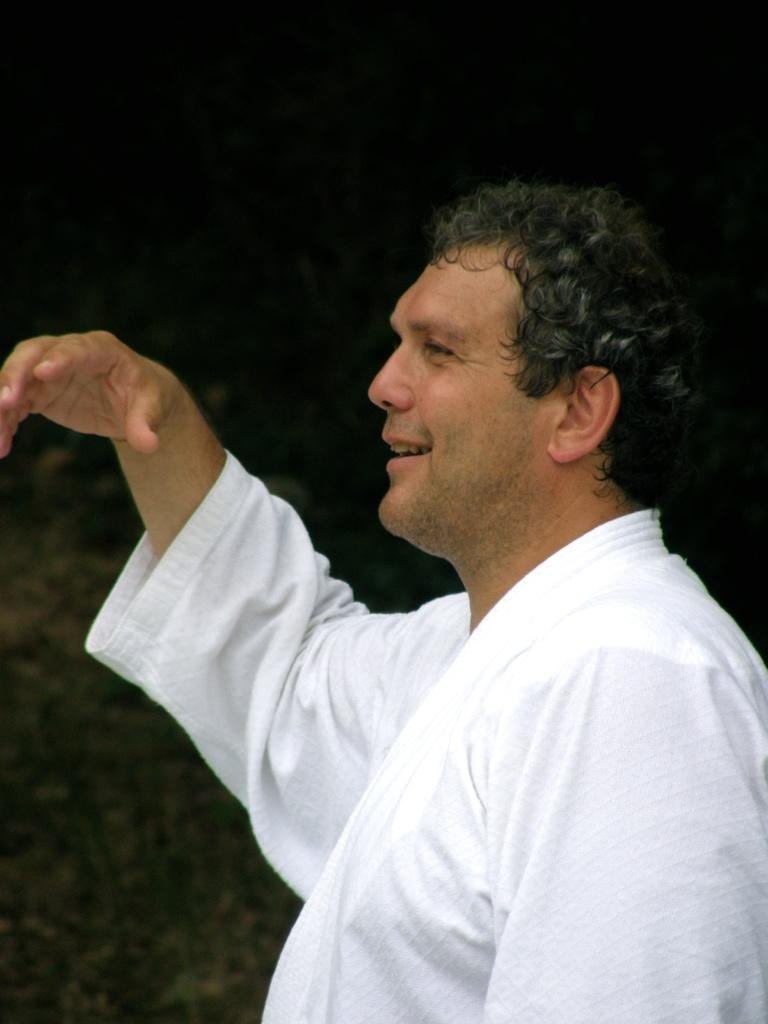What is the main subject of the image? There is a person in the image. What is the person doing in the image? The person is standing. What is the facial expression of the person? The person has a smiling face. What is the person wearing in the image? The person is wearing a white dress. What can be observed about the background of the image? The background of the image is dark. What type of pets can be seen playing with ice in the image? There are no pets or ice present in the image; it features a person standing with a smiling face. 